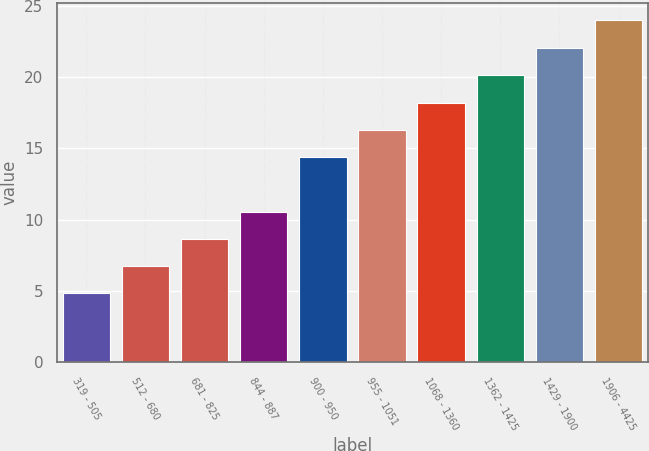Convert chart to OTSL. <chart><loc_0><loc_0><loc_500><loc_500><bar_chart><fcel>319 - 505<fcel>512 - 680<fcel>681 - 825<fcel>844 - 887<fcel>900 - 950<fcel>955 - 1051<fcel>1068 - 1360<fcel>1362 - 1425<fcel>1429 - 1900<fcel>1906 - 4425<nl><fcel>4.84<fcel>6.75<fcel>8.66<fcel>10.57<fcel>14.39<fcel>16.3<fcel>18.21<fcel>20.12<fcel>22.04<fcel>23.99<nl></chart> 